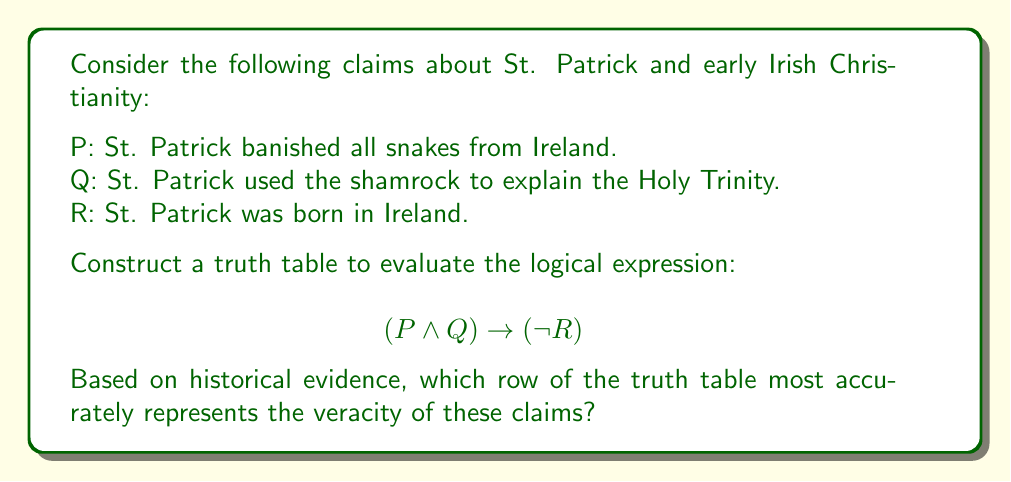Solve this math problem. To solve this problem, we need to follow these steps:

1. Construct the truth table for the given logical expression.
2. Evaluate the historical accuracy of each claim.
3. Identify the row in the truth table that matches the historical evidence.

Step 1: Constructing the truth table

Let's create a truth table for the expression $$(P \land Q) \rightarrow (\neg R)$$

$$\begin{array}{|c|c|c|c|c|c|}
\hline
P & Q & R & P \land Q & \neg R & (P \land Q) \rightarrow (\neg R) \\
\hline
T & T & T & T & F & F \\
T & T & F & T & T & T \\
T & F & T & F & F & T \\
T & F & F & F & T & T \\
F & T & T & F & F & T \\
F & T & F & F & T & T \\
F & F & T & F & F & T \\
F & F & F & F & T & T \\
\hline
\end{array}$$

Step 2: Evaluating historical accuracy

Now, let's examine the historical evidence for each claim:

P: St. Patrick banished all snakes from Ireland.
   This is a legend with no historical basis. Ireland has been snake-free since the last Ice Age, long before St. Patrick's time. FALSE

Q: St. Patrick used the shamrock to explain the Holy Trinity.
   While this is a popular legend, there's no concrete historical evidence to support it. It first appeared in literature centuries after St. Patrick's death. However, it's plausible and consistent with his teaching methods. We can consider this POSSIBLY TRUE.

R: St. Patrick was born in Ireland.
   Historical evidence suggests that St. Patrick was born in Roman Britain, not in Ireland. He was brought to Ireland as a slave in his youth. FALSE

Step 3: Identifying the matching row

Based on our historical analysis:
P is False
Q is possibly True (we'll consider it True for this logical analysis)
R is False

This combination corresponds to the 6th row of our truth table:

$$\begin{array}{|c|c|c|c|c|c|}
\hline
P & Q & R & P \land Q & \neg R & (P \land Q) \rightarrow (\neg R) \\
\hline
F & T & F & F & T & T \\
\hline
\end{array}$$
Answer: The 6th row of the truth table (F, T, F) most accurately represents the historical veracity of the claims about St. Patrick and early Irish Christianity. 